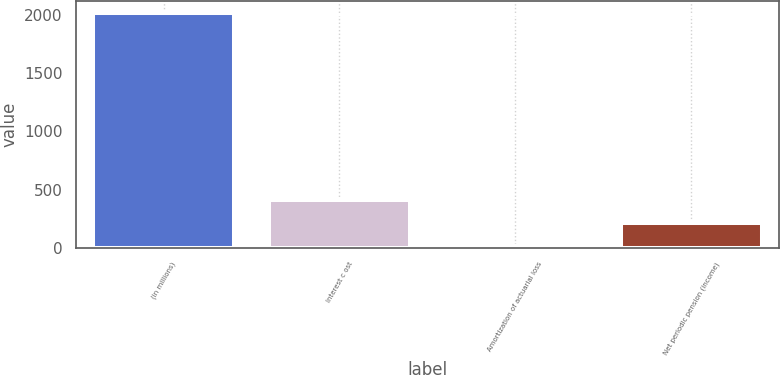Convert chart to OTSL. <chart><loc_0><loc_0><loc_500><loc_500><bar_chart><fcel>(in millions)<fcel>Interest c ost<fcel>Amortization of actuarial loss<fcel>Net periodic pension (income)<nl><fcel>2015<fcel>413.4<fcel>13<fcel>213.2<nl></chart> 